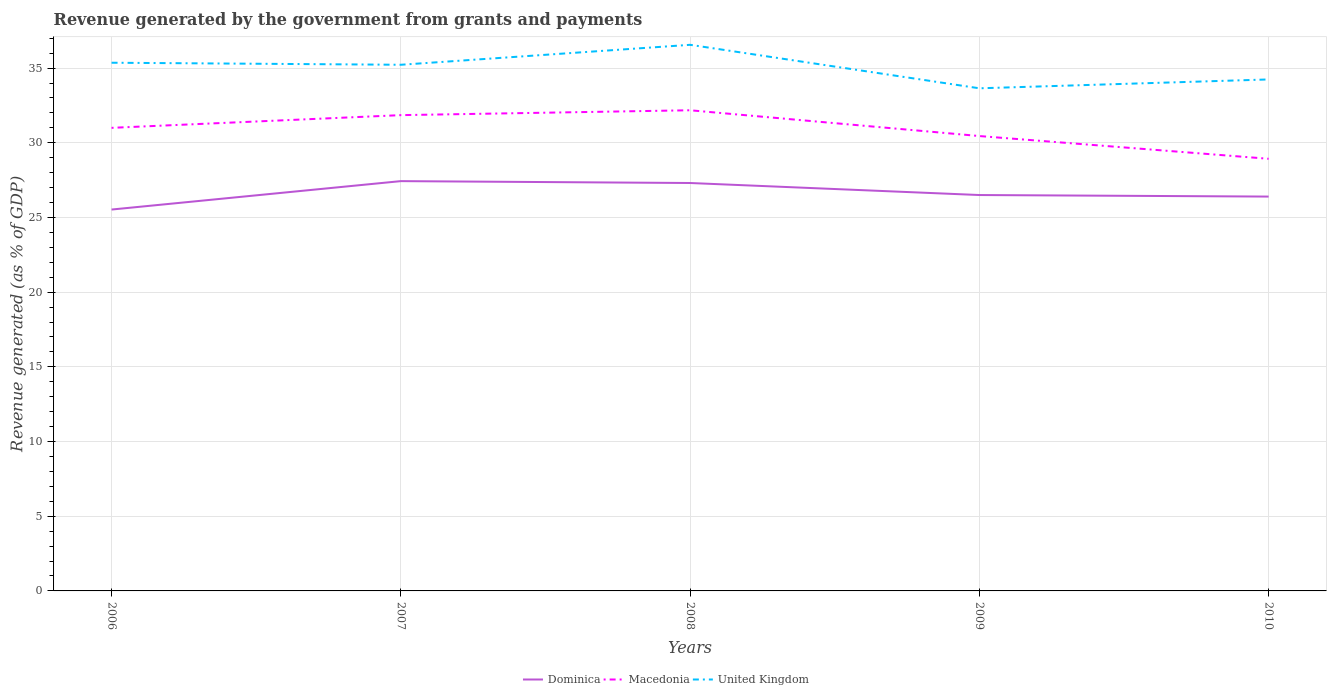How many different coloured lines are there?
Provide a succinct answer. 3. Across all years, what is the maximum revenue generated by the government in United Kingdom?
Make the answer very short. 33.65. In which year was the revenue generated by the government in Dominica maximum?
Your response must be concise. 2006. What is the total revenue generated by the government in Macedonia in the graph?
Ensure brevity in your answer.  2.07. What is the difference between the highest and the second highest revenue generated by the government in Dominica?
Your answer should be very brief. 1.9. How many years are there in the graph?
Provide a succinct answer. 5. What is the title of the graph?
Offer a terse response. Revenue generated by the government from grants and payments. What is the label or title of the X-axis?
Provide a short and direct response. Years. What is the label or title of the Y-axis?
Your answer should be compact. Revenue generated (as % of GDP). What is the Revenue generated (as % of GDP) in Dominica in 2006?
Provide a succinct answer. 25.53. What is the Revenue generated (as % of GDP) in Macedonia in 2006?
Offer a very short reply. 31. What is the Revenue generated (as % of GDP) in United Kingdom in 2006?
Offer a terse response. 35.36. What is the Revenue generated (as % of GDP) in Dominica in 2007?
Your response must be concise. 27.43. What is the Revenue generated (as % of GDP) of Macedonia in 2007?
Offer a terse response. 31.85. What is the Revenue generated (as % of GDP) in United Kingdom in 2007?
Keep it short and to the point. 35.22. What is the Revenue generated (as % of GDP) of Dominica in 2008?
Provide a succinct answer. 27.31. What is the Revenue generated (as % of GDP) in Macedonia in 2008?
Keep it short and to the point. 32.18. What is the Revenue generated (as % of GDP) in United Kingdom in 2008?
Give a very brief answer. 36.56. What is the Revenue generated (as % of GDP) in Dominica in 2009?
Ensure brevity in your answer.  26.5. What is the Revenue generated (as % of GDP) in Macedonia in 2009?
Your answer should be very brief. 30.45. What is the Revenue generated (as % of GDP) in United Kingdom in 2009?
Provide a succinct answer. 33.65. What is the Revenue generated (as % of GDP) in Dominica in 2010?
Your answer should be very brief. 26.4. What is the Revenue generated (as % of GDP) of Macedonia in 2010?
Your answer should be very brief. 28.93. What is the Revenue generated (as % of GDP) of United Kingdom in 2010?
Provide a succinct answer. 34.24. Across all years, what is the maximum Revenue generated (as % of GDP) of Dominica?
Offer a very short reply. 27.43. Across all years, what is the maximum Revenue generated (as % of GDP) of Macedonia?
Make the answer very short. 32.18. Across all years, what is the maximum Revenue generated (as % of GDP) of United Kingdom?
Your answer should be very brief. 36.56. Across all years, what is the minimum Revenue generated (as % of GDP) in Dominica?
Your answer should be very brief. 25.53. Across all years, what is the minimum Revenue generated (as % of GDP) of Macedonia?
Your answer should be very brief. 28.93. Across all years, what is the minimum Revenue generated (as % of GDP) of United Kingdom?
Your response must be concise. 33.65. What is the total Revenue generated (as % of GDP) of Dominica in the graph?
Ensure brevity in your answer.  133.18. What is the total Revenue generated (as % of GDP) in Macedonia in the graph?
Offer a very short reply. 154.41. What is the total Revenue generated (as % of GDP) of United Kingdom in the graph?
Your answer should be very brief. 175.03. What is the difference between the Revenue generated (as % of GDP) in Dominica in 2006 and that in 2007?
Keep it short and to the point. -1.9. What is the difference between the Revenue generated (as % of GDP) of Macedonia in 2006 and that in 2007?
Your response must be concise. -0.85. What is the difference between the Revenue generated (as % of GDP) in United Kingdom in 2006 and that in 2007?
Ensure brevity in your answer.  0.14. What is the difference between the Revenue generated (as % of GDP) of Dominica in 2006 and that in 2008?
Offer a very short reply. -1.78. What is the difference between the Revenue generated (as % of GDP) in Macedonia in 2006 and that in 2008?
Give a very brief answer. -1.18. What is the difference between the Revenue generated (as % of GDP) in United Kingdom in 2006 and that in 2008?
Give a very brief answer. -1.2. What is the difference between the Revenue generated (as % of GDP) in Dominica in 2006 and that in 2009?
Keep it short and to the point. -0.97. What is the difference between the Revenue generated (as % of GDP) of Macedonia in 2006 and that in 2009?
Offer a very short reply. 0.55. What is the difference between the Revenue generated (as % of GDP) of United Kingdom in 2006 and that in 2009?
Ensure brevity in your answer.  1.71. What is the difference between the Revenue generated (as % of GDP) in Dominica in 2006 and that in 2010?
Your answer should be very brief. -0.87. What is the difference between the Revenue generated (as % of GDP) of Macedonia in 2006 and that in 2010?
Your answer should be very brief. 2.07. What is the difference between the Revenue generated (as % of GDP) in United Kingdom in 2006 and that in 2010?
Make the answer very short. 1.12. What is the difference between the Revenue generated (as % of GDP) of Dominica in 2007 and that in 2008?
Your answer should be compact. 0.13. What is the difference between the Revenue generated (as % of GDP) of Macedonia in 2007 and that in 2008?
Ensure brevity in your answer.  -0.33. What is the difference between the Revenue generated (as % of GDP) in United Kingdom in 2007 and that in 2008?
Provide a succinct answer. -1.34. What is the difference between the Revenue generated (as % of GDP) of Dominica in 2007 and that in 2009?
Your answer should be compact. 0.93. What is the difference between the Revenue generated (as % of GDP) of Macedonia in 2007 and that in 2009?
Your response must be concise. 1.4. What is the difference between the Revenue generated (as % of GDP) in United Kingdom in 2007 and that in 2009?
Provide a short and direct response. 1.58. What is the difference between the Revenue generated (as % of GDP) of Dominica in 2007 and that in 2010?
Your answer should be compact. 1.03. What is the difference between the Revenue generated (as % of GDP) in Macedonia in 2007 and that in 2010?
Your answer should be compact. 2.92. What is the difference between the Revenue generated (as % of GDP) of United Kingdom in 2007 and that in 2010?
Your response must be concise. 0.98. What is the difference between the Revenue generated (as % of GDP) in Dominica in 2008 and that in 2009?
Make the answer very short. 0.81. What is the difference between the Revenue generated (as % of GDP) of Macedonia in 2008 and that in 2009?
Provide a short and direct response. 1.73. What is the difference between the Revenue generated (as % of GDP) of United Kingdom in 2008 and that in 2009?
Offer a very short reply. 2.91. What is the difference between the Revenue generated (as % of GDP) of Dominica in 2008 and that in 2010?
Keep it short and to the point. 0.91. What is the difference between the Revenue generated (as % of GDP) in Macedonia in 2008 and that in 2010?
Provide a succinct answer. 3.25. What is the difference between the Revenue generated (as % of GDP) of United Kingdom in 2008 and that in 2010?
Keep it short and to the point. 2.32. What is the difference between the Revenue generated (as % of GDP) in Dominica in 2009 and that in 2010?
Your answer should be very brief. 0.1. What is the difference between the Revenue generated (as % of GDP) of Macedonia in 2009 and that in 2010?
Keep it short and to the point. 1.52. What is the difference between the Revenue generated (as % of GDP) of United Kingdom in 2009 and that in 2010?
Give a very brief answer. -0.59. What is the difference between the Revenue generated (as % of GDP) in Dominica in 2006 and the Revenue generated (as % of GDP) in Macedonia in 2007?
Your answer should be compact. -6.32. What is the difference between the Revenue generated (as % of GDP) of Dominica in 2006 and the Revenue generated (as % of GDP) of United Kingdom in 2007?
Offer a terse response. -9.69. What is the difference between the Revenue generated (as % of GDP) of Macedonia in 2006 and the Revenue generated (as % of GDP) of United Kingdom in 2007?
Provide a succinct answer. -4.22. What is the difference between the Revenue generated (as % of GDP) of Dominica in 2006 and the Revenue generated (as % of GDP) of Macedonia in 2008?
Offer a very short reply. -6.65. What is the difference between the Revenue generated (as % of GDP) of Dominica in 2006 and the Revenue generated (as % of GDP) of United Kingdom in 2008?
Ensure brevity in your answer.  -11.03. What is the difference between the Revenue generated (as % of GDP) of Macedonia in 2006 and the Revenue generated (as % of GDP) of United Kingdom in 2008?
Offer a terse response. -5.56. What is the difference between the Revenue generated (as % of GDP) of Dominica in 2006 and the Revenue generated (as % of GDP) of Macedonia in 2009?
Make the answer very short. -4.92. What is the difference between the Revenue generated (as % of GDP) in Dominica in 2006 and the Revenue generated (as % of GDP) in United Kingdom in 2009?
Your answer should be compact. -8.12. What is the difference between the Revenue generated (as % of GDP) in Macedonia in 2006 and the Revenue generated (as % of GDP) in United Kingdom in 2009?
Provide a short and direct response. -2.65. What is the difference between the Revenue generated (as % of GDP) of Dominica in 2006 and the Revenue generated (as % of GDP) of Macedonia in 2010?
Your response must be concise. -3.4. What is the difference between the Revenue generated (as % of GDP) in Dominica in 2006 and the Revenue generated (as % of GDP) in United Kingdom in 2010?
Your answer should be very brief. -8.71. What is the difference between the Revenue generated (as % of GDP) in Macedonia in 2006 and the Revenue generated (as % of GDP) in United Kingdom in 2010?
Give a very brief answer. -3.24. What is the difference between the Revenue generated (as % of GDP) in Dominica in 2007 and the Revenue generated (as % of GDP) in Macedonia in 2008?
Provide a short and direct response. -4.74. What is the difference between the Revenue generated (as % of GDP) of Dominica in 2007 and the Revenue generated (as % of GDP) of United Kingdom in 2008?
Keep it short and to the point. -9.13. What is the difference between the Revenue generated (as % of GDP) of Macedonia in 2007 and the Revenue generated (as % of GDP) of United Kingdom in 2008?
Provide a succinct answer. -4.71. What is the difference between the Revenue generated (as % of GDP) of Dominica in 2007 and the Revenue generated (as % of GDP) of Macedonia in 2009?
Your response must be concise. -3.02. What is the difference between the Revenue generated (as % of GDP) of Dominica in 2007 and the Revenue generated (as % of GDP) of United Kingdom in 2009?
Give a very brief answer. -6.21. What is the difference between the Revenue generated (as % of GDP) in Macedonia in 2007 and the Revenue generated (as % of GDP) in United Kingdom in 2009?
Make the answer very short. -1.8. What is the difference between the Revenue generated (as % of GDP) in Dominica in 2007 and the Revenue generated (as % of GDP) in Macedonia in 2010?
Your answer should be very brief. -1.5. What is the difference between the Revenue generated (as % of GDP) in Dominica in 2007 and the Revenue generated (as % of GDP) in United Kingdom in 2010?
Provide a short and direct response. -6.81. What is the difference between the Revenue generated (as % of GDP) in Macedonia in 2007 and the Revenue generated (as % of GDP) in United Kingdom in 2010?
Give a very brief answer. -2.39. What is the difference between the Revenue generated (as % of GDP) of Dominica in 2008 and the Revenue generated (as % of GDP) of Macedonia in 2009?
Offer a terse response. -3.14. What is the difference between the Revenue generated (as % of GDP) of Dominica in 2008 and the Revenue generated (as % of GDP) of United Kingdom in 2009?
Your answer should be very brief. -6.34. What is the difference between the Revenue generated (as % of GDP) of Macedonia in 2008 and the Revenue generated (as % of GDP) of United Kingdom in 2009?
Provide a succinct answer. -1.47. What is the difference between the Revenue generated (as % of GDP) in Dominica in 2008 and the Revenue generated (as % of GDP) in Macedonia in 2010?
Offer a terse response. -1.62. What is the difference between the Revenue generated (as % of GDP) of Dominica in 2008 and the Revenue generated (as % of GDP) of United Kingdom in 2010?
Your response must be concise. -6.93. What is the difference between the Revenue generated (as % of GDP) of Macedonia in 2008 and the Revenue generated (as % of GDP) of United Kingdom in 2010?
Your answer should be compact. -2.06. What is the difference between the Revenue generated (as % of GDP) of Dominica in 2009 and the Revenue generated (as % of GDP) of Macedonia in 2010?
Keep it short and to the point. -2.43. What is the difference between the Revenue generated (as % of GDP) of Dominica in 2009 and the Revenue generated (as % of GDP) of United Kingdom in 2010?
Provide a short and direct response. -7.74. What is the difference between the Revenue generated (as % of GDP) of Macedonia in 2009 and the Revenue generated (as % of GDP) of United Kingdom in 2010?
Provide a succinct answer. -3.79. What is the average Revenue generated (as % of GDP) in Dominica per year?
Offer a very short reply. 26.64. What is the average Revenue generated (as % of GDP) in Macedonia per year?
Your answer should be very brief. 30.88. What is the average Revenue generated (as % of GDP) of United Kingdom per year?
Provide a short and direct response. 35.01. In the year 2006, what is the difference between the Revenue generated (as % of GDP) of Dominica and Revenue generated (as % of GDP) of Macedonia?
Ensure brevity in your answer.  -5.47. In the year 2006, what is the difference between the Revenue generated (as % of GDP) in Dominica and Revenue generated (as % of GDP) in United Kingdom?
Provide a succinct answer. -9.83. In the year 2006, what is the difference between the Revenue generated (as % of GDP) in Macedonia and Revenue generated (as % of GDP) in United Kingdom?
Offer a terse response. -4.36. In the year 2007, what is the difference between the Revenue generated (as % of GDP) in Dominica and Revenue generated (as % of GDP) in Macedonia?
Your answer should be very brief. -4.42. In the year 2007, what is the difference between the Revenue generated (as % of GDP) of Dominica and Revenue generated (as % of GDP) of United Kingdom?
Keep it short and to the point. -7.79. In the year 2007, what is the difference between the Revenue generated (as % of GDP) in Macedonia and Revenue generated (as % of GDP) in United Kingdom?
Offer a terse response. -3.37. In the year 2008, what is the difference between the Revenue generated (as % of GDP) in Dominica and Revenue generated (as % of GDP) in Macedonia?
Keep it short and to the point. -4.87. In the year 2008, what is the difference between the Revenue generated (as % of GDP) of Dominica and Revenue generated (as % of GDP) of United Kingdom?
Give a very brief answer. -9.25. In the year 2008, what is the difference between the Revenue generated (as % of GDP) in Macedonia and Revenue generated (as % of GDP) in United Kingdom?
Make the answer very short. -4.38. In the year 2009, what is the difference between the Revenue generated (as % of GDP) of Dominica and Revenue generated (as % of GDP) of Macedonia?
Your answer should be very brief. -3.95. In the year 2009, what is the difference between the Revenue generated (as % of GDP) in Dominica and Revenue generated (as % of GDP) in United Kingdom?
Your answer should be very brief. -7.15. In the year 2009, what is the difference between the Revenue generated (as % of GDP) of Macedonia and Revenue generated (as % of GDP) of United Kingdom?
Keep it short and to the point. -3.2. In the year 2010, what is the difference between the Revenue generated (as % of GDP) of Dominica and Revenue generated (as % of GDP) of Macedonia?
Provide a short and direct response. -2.53. In the year 2010, what is the difference between the Revenue generated (as % of GDP) of Dominica and Revenue generated (as % of GDP) of United Kingdom?
Your answer should be compact. -7.84. In the year 2010, what is the difference between the Revenue generated (as % of GDP) of Macedonia and Revenue generated (as % of GDP) of United Kingdom?
Offer a very short reply. -5.31. What is the ratio of the Revenue generated (as % of GDP) of Dominica in 2006 to that in 2007?
Your answer should be compact. 0.93. What is the ratio of the Revenue generated (as % of GDP) of Macedonia in 2006 to that in 2007?
Your answer should be very brief. 0.97. What is the ratio of the Revenue generated (as % of GDP) in Dominica in 2006 to that in 2008?
Offer a very short reply. 0.93. What is the ratio of the Revenue generated (as % of GDP) of Macedonia in 2006 to that in 2008?
Make the answer very short. 0.96. What is the ratio of the Revenue generated (as % of GDP) of United Kingdom in 2006 to that in 2008?
Your response must be concise. 0.97. What is the ratio of the Revenue generated (as % of GDP) in Dominica in 2006 to that in 2009?
Ensure brevity in your answer.  0.96. What is the ratio of the Revenue generated (as % of GDP) of United Kingdom in 2006 to that in 2009?
Make the answer very short. 1.05. What is the ratio of the Revenue generated (as % of GDP) of Dominica in 2006 to that in 2010?
Offer a terse response. 0.97. What is the ratio of the Revenue generated (as % of GDP) of Macedonia in 2006 to that in 2010?
Provide a short and direct response. 1.07. What is the ratio of the Revenue generated (as % of GDP) in United Kingdom in 2006 to that in 2010?
Your response must be concise. 1.03. What is the ratio of the Revenue generated (as % of GDP) in Dominica in 2007 to that in 2008?
Your answer should be compact. 1. What is the ratio of the Revenue generated (as % of GDP) of United Kingdom in 2007 to that in 2008?
Keep it short and to the point. 0.96. What is the ratio of the Revenue generated (as % of GDP) of Dominica in 2007 to that in 2009?
Keep it short and to the point. 1.04. What is the ratio of the Revenue generated (as % of GDP) in Macedonia in 2007 to that in 2009?
Offer a terse response. 1.05. What is the ratio of the Revenue generated (as % of GDP) of United Kingdom in 2007 to that in 2009?
Provide a succinct answer. 1.05. What is the ratio of the Revenue generated (as % of GDP) of Dominica in 2007 to that in 2010?
Offer a very short reply. 1.04. What is the ratio of the Revenue generated (as % of GDP) in Macedonia in 2007 to that in 2010?
Give a very brief answer. 1.1. What is the ratio of the Revenue generated (as % of GDP) of United Kingdom in 2007 to that in 2010?
Give a very brief answer. 1.03. What is the ratio of the Revenue generated (as % of GDP) in Dominica in 2008 to that in 2009?
Give a very brief answer. 1.03. What is the ratio of the Revenue generated (as % of GDP) in Macedonia in 2008 to that in 2009?
Your answer should be very brief. 1.06. What is the ratio of the Revenue generated (as % of GDP) in United Kingdom in 2008 to that in 2009?
Offer a very short reply. 1.09. What is the ratio of the Revenue generated (as % of GDP) of Dominica in 2008 to that in 2010?
Your response must be concise. 1.03. What is the ratio of the Revenue generated (as % of GDP) of Macedonia in 2008 to that in 2010?
Your answer should be very brief. 1.11. What is the ratio of the Revenue generated (as % of GDP) in United Kingdom in 2008 to that in 2010?
Provide a short and direct response. 1.07. What is the ratio of the Revenue generated (as % of GDP) in Dominica in 2009 to that in 2010?
Ensure brevity in your answer.  1. What is the ratio of the Revenue generated (as % of GDP) of Macedonia in 2009 to that in 2010?
Offer a very short reply. 1.05. What is the ratio of the Revenue generated (as % of GDP) in United Kingdom in 2009 to that in 2010?
Your answer should be very brief. 0.98. What is the difference between the highest and the second highest Revenue generated (as % of GDP) in Dominica?
Offer a very short reply. 0.13. What is the difference between the highest and the second highest Revenue generated (as % of GDP) of Macedonia?
Give a very brief answer. 0.33. What is the difference between the highest and the second highest Revenue generated (as % of GDP) in United Kingdom?
Your answer should be very brief. 1.2. What is the difference between the highest and the lowest Revenue generated (as % of GDP) of Dominica?
Provide a short and direct response. 1.9. What is the difference between the highest and the lowest Revenue generated (as % of GDP) in Macedonia?
Your answer should be very brief. 3.25. What is the difference between the highest and the lowest Revenue generated (as % of GDP) in United Kingdom?
Offer a terse response. 2.91. 